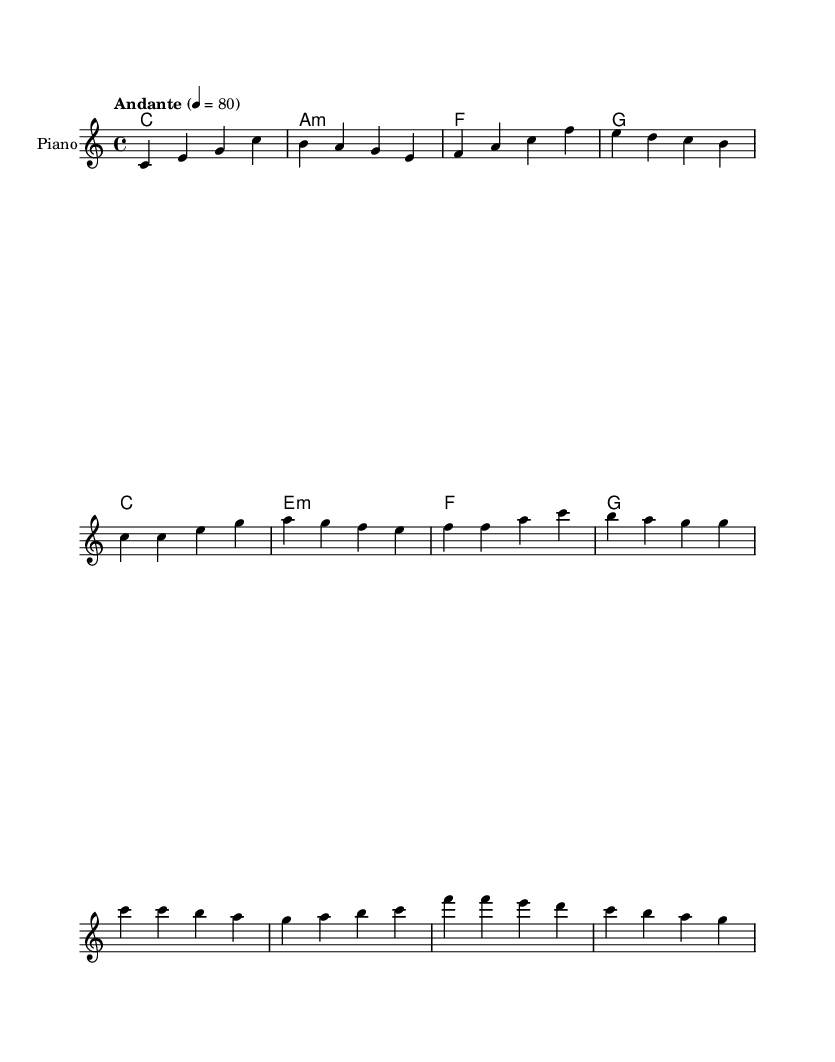What is the key signature of this music? The key signature is identified by looking for the sharp or flat symbols at the beginning of the staff. In this sheet music, there are no sharps or flats indicated, which corresponds to C major.
Answer: C major What is the time signature of this music? The time signature is shown at the beginning of the music after the key signature. In this case, it is indicated as 4/4, meaning there are four beats in each measure and the quarter note gets one beat.
Answer: 4/4 What is the indicated tempo of the piece? The tempo is written above the staff and indicates how fast the music should be played. Here, it is stated as "Andante" with a metronome marking of 80 beats per minute.
Answer: Andante, 80 How many measures are in the verse? To find the number of measures in the verse, we count the individual measures between the annotations in the sheet music. The verse spans from the first measure of the verse to the last, totaling six measures.
Answer: Six measures What are the main themes of the lyrics? The themes of the lyrics can be discerned from the text written below the melody. The verses focus on unity and sharing wisdom, while the chorus emphasizes harmony and celebration of diversity.
Answer: Unity, harmony, celebration What chord follows the C major chord in the harmony? To identify the chord that follows C major, we look at the chord symbols written above the melody. After the C major chord, the next chord is A minor, as shown in the chord progression sequence.
Answer: A minor How does the melody change in the chorus compared to the verse? Analyzing the melody sections, the chorus features a shift in pitch patterns and rhythm, creating a more uplifting and celebratory feel compared to the verse, which is more reflective.
Answer: It becomes more uplifting 